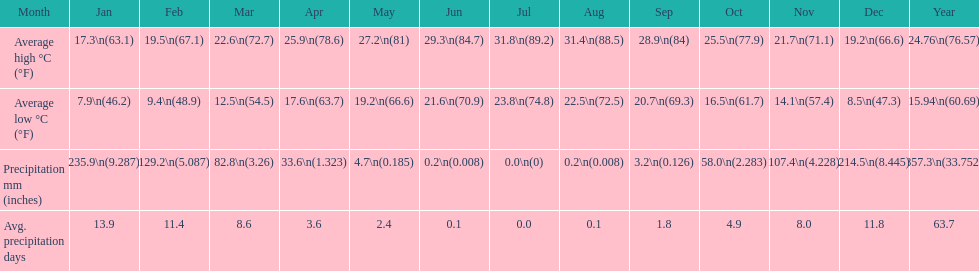Which country is haifa in? Israel. 